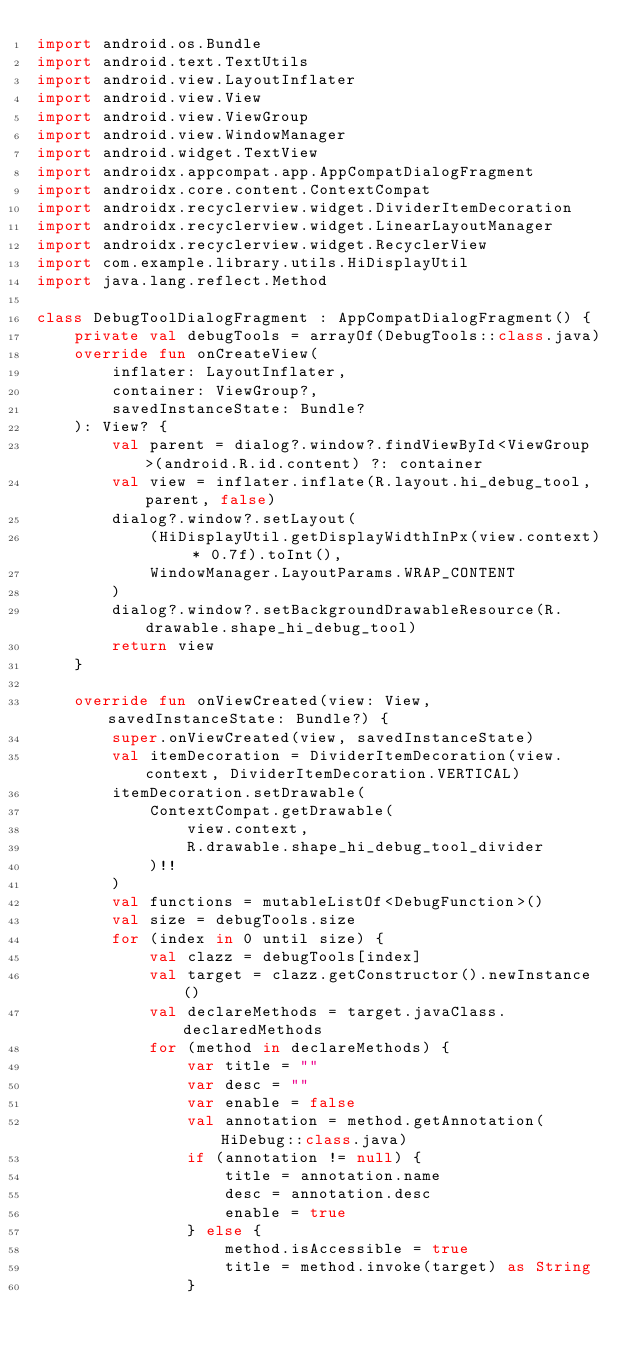<code> <loc_0><loc_0><loc_500><loc_500><_Kotlin_>import android.os.Bundle
import android.text.TextUtils
import android.view.LayoutInflater
import android.view.View
import android.view.ViewGroup
import android.view.WindowManager
import android.widget.TextView
import androidx.appcompat.app.AppCompatDialogFragment
import androidx.core.content.ContextCompat
import androidx.recyclerview.widget.DividerItemDecoration
import androidx.recyclerview.widget.LinearLayoutManager
import androidx.recyclerview.widget.RecyclerView
import com.example.library.utils.HiDisplayUtil
import java.lang.reflect.Method

class DebugToolDialogFragment : AppCompatDialogFragment() {
    private val debugTools = arrayOf(DebugTools::class.java)
    override fun onCreateView(
        inflater: LayoutInflater,
        container: ViewGroup?,
        savedInstanceState: Bundle?
    ): View? {
        val parent = dialog?.window?.findViewById<ViewGroup>(android.R.id.content) ?: container
        val view = inflater.inflate(R.layout.hi_debug_tool, parent, false)
        dialog?.window?.setLayout(
            (HiDisplayUtil.getDisplayWidthInPx(view.context) * 0.7f).toInt(),
            WindowManager.LayoutParams.WRAP_CONTENT
        )
        dialog?.window?.setBackgroundDrawableResource(R.drawable.shape_hi_debug_tool)
        return view
    }

    override fun onViewCreated(view: View, savedInstanceState: Bundle?) {
        super.onViewCreated(view, savedInstanceState)
        val itemDecoration = DividerItemDecoration(view.context, DividerItemDecoration.VERTICAL)
        itemDecoration.setDrawable(
            ContextCompat.getDrawable(
                view.context,
                R.drawable.shape_hi_debug_tool_divider
            )!!
        )
        val functions = mutableListOf<DebugFunction>()
        val size = debugTools.size
        for (index in 0 until size) {
            val clazz = debugTools[index]
            val target = clazz.getConstructor().newInstance()
            val declareMethods = target.javaClass.declaredMethods
            for (method in declareMethods) {
                var title = ""
                var desc = ""
                var enable = false
                val annotation = method.getAnnotation(HiDebug::class.java)
                if (annotation != null) {
                    title = annotation.name
                    desc = annotation.desc
                    enable = true
                } else {
                    method.isAccessible = true
                    title = method.invoke(target) as String
                }
</code> 